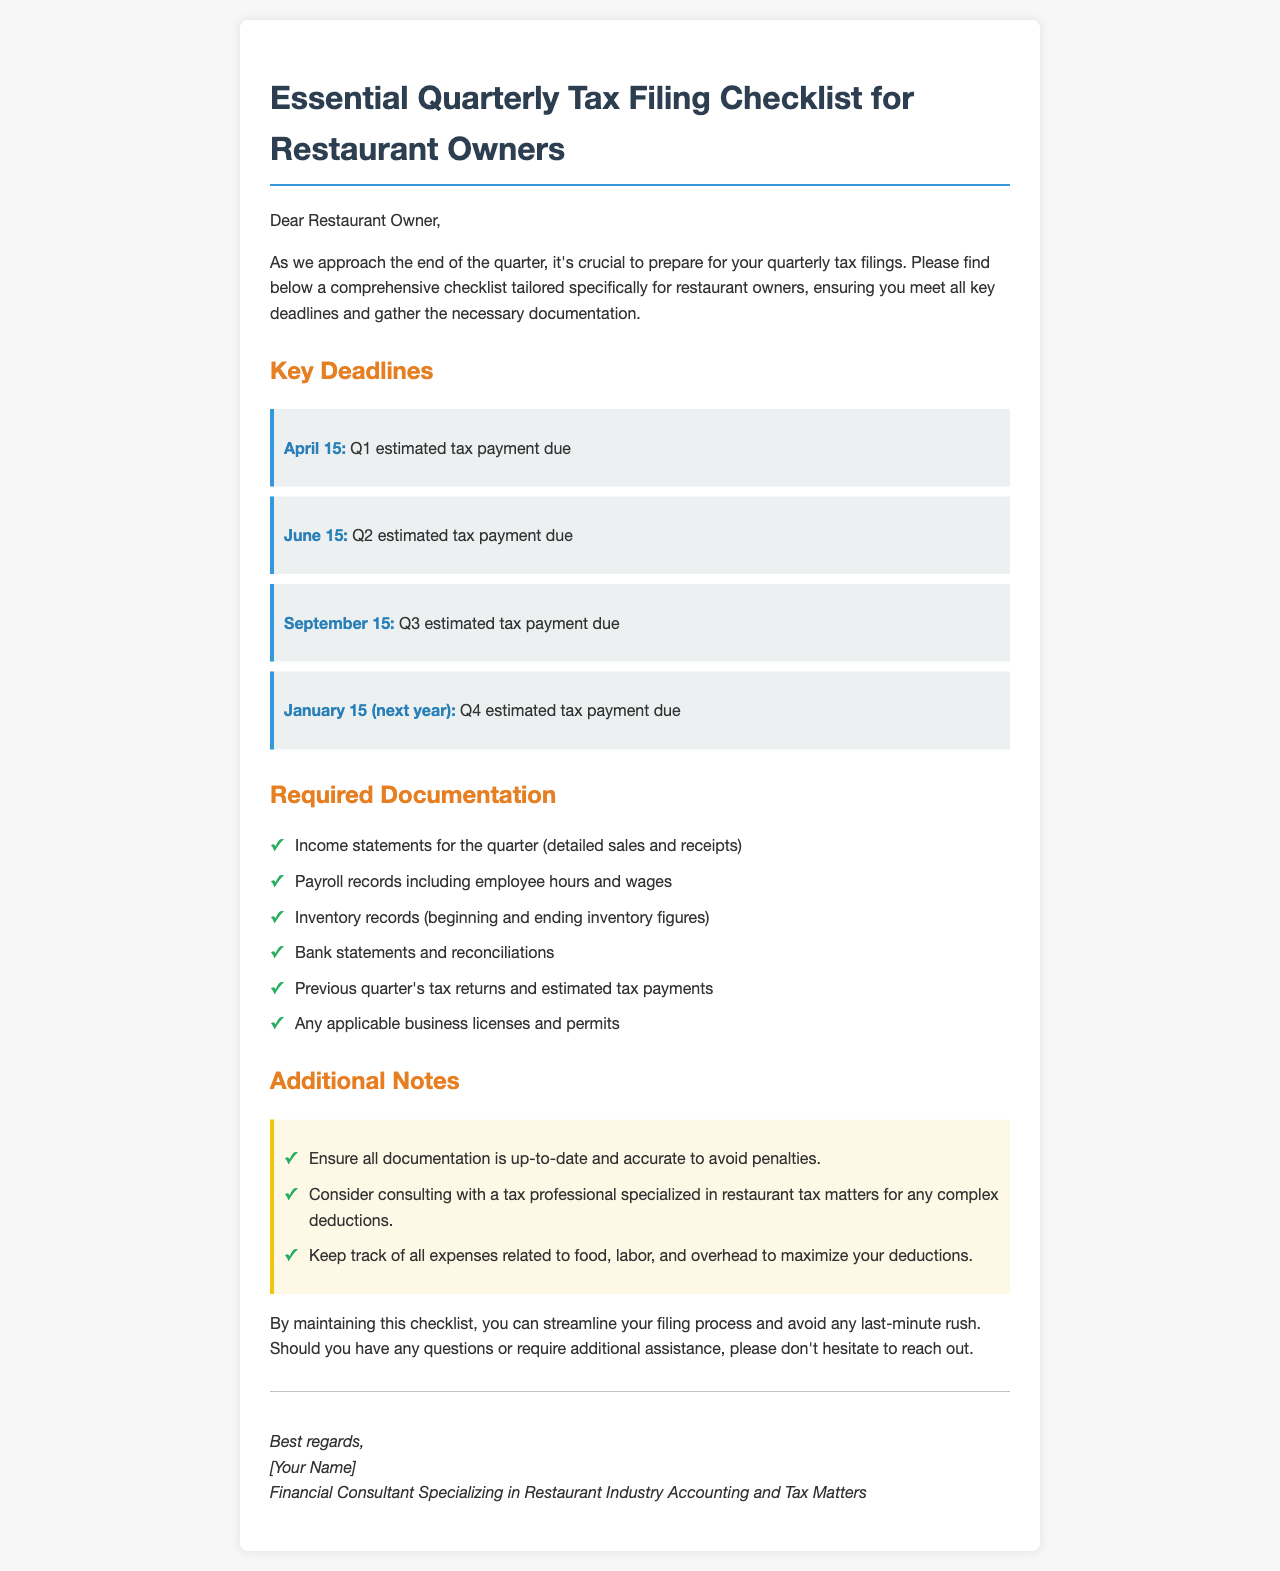What is the deadline for Q1 estimated tax payment? The deadline for Q1 estimated tax payment is specified in the document as April 15.
Answer: April 15 What documents are needed for payroll records? The document specifies that payroll records must include employee hours and wages.
Answer: Employee hours and wages When is the Q2 estimated tax payment due? The specific due date for the Q2 estimated tax payment is listed as June 15 in the document.
Answer: June 15 What type of records should be maintained for inventory? The checklist mentions that beginning and ending inventory figures should be kept.
Answer: Beginning and ending inventory figures What additional advice is given for tax deductions? The document suggests keeping track of all expenses related to food, labor, and overhead to maximize deductions.
Answer: Keep track of all expenses related to food, labor, and overhead How many estimated tax payment deadlines are mentioned? The document lists four specific estimated tax payment deadlines throughout the year.
Answer: Four What should be ensured about the documentation? The document states that all documentation should be up-to-date and accurate to avoid penalties.
Answer: Up-to-date and accurate What is suggested for consulting tax matters? The checklist advises consulting with a tax professional specialized in restaurant tax matters for complex deductions.
Answer: Tax professional specialized in restaurant tax matters 